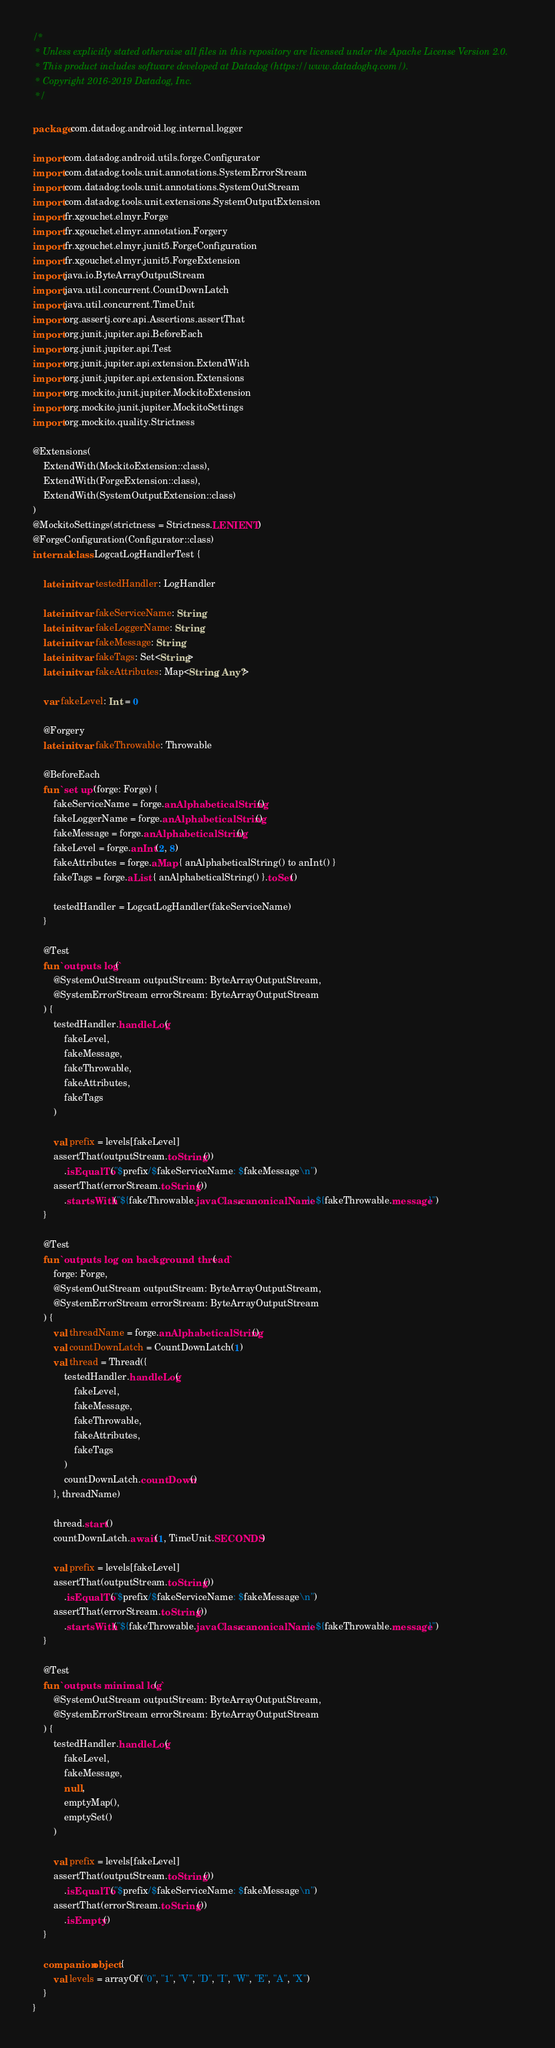Convert code to text. <code><loc_0><loc_0><loc_500><loc_500><_Kotlin_>/*
 * Unless explicitly stated otherwise all files in this repository are licensed under the Apache License Version 2.0.
 * This product includes software developed at Datadog (https://www.datadoghq.com/).
 * Copyright 2016-2019 Datadog, Inc.
 */

package com.datadog.android.log.internal.logger

import com.datadog.android.utils.forge.Configurator
import com.datadog.tools.unit.annotations.SystemErrorStream
import com.datadog.tools.unit.annotations.SystemOutStream
import com.datadog.tools.unit.extensions.SystemOutputExtension
import fr.xgouchet.elmyr.Forge
import fr.xgouchet.elmyr.annotation.Forgery
import fr.xgouchet.elmyr.junit5.ForgeConfiguration
import fr.xgouchet.elmyr.junit5.ForgeExtension
import java.io.ByteArrayOutputStream
import java.util.concurrent.CountDownLatch
import java.util.concurrent.TimeUnit
import org.assertj.core.api.Assertions.assertThat
import org.junit.jupiter.api.BeforeEach
import org.junit.jupiter.api.Test
import org.junit.jupiter.api.extension.ExtendWith
import org.junit.jupiter.api.extension.Extensions
import org.mockito.junit.jupiter.MockitoExtension
import org.mockito.junit.jupiter.MockitoSettings
import org.mockito.quality.Strictness

@Extensions(
    ExtendWith(MockitoExtension::class),
    ExtendWith(ForgeExtension::class),
    ExtendWith(SystemOutputExtension::class)
)
@MockitoSettings(strictness = Strictness.LENIENT)
@ForgeConfiguration(Configurator::class)
internal class LogcatLogHandlerTest {

    lateinit var testedHandler: LogHandler

    lateinit var fakeServiceName: String
    lateinit var fakeLoggerName: String
    lateinit var fakeMessage: String
    lateinit var fakeTags: Set<String>
    lateinit var fakeAttributes: Map<String, Any?>

    var fakeLevel: Int = 0

    @Forgery
    lateinit var fakeThrowable: Throwable

    @BeforeEach
    fun `set up`(forge: Forge) {
        fakeServiceName = forge.anAlphabeticalString()
        fakeLoggerName = forge.anAlphabeticalString()
        fakeMessage = forge.anAlphabeticalString()
        fakeLevel = forge.anInt(2, 8)
        fakeAttributes = forge.aMap { anAlphabeticalString() to anInt() }
        fakeTags = forge.aList { anAlphabeticalString() }.toSet()

        testedHandler = LogcatLogHandler(fakeServiceName)
    }

    @Test
    fun `outputs log`(
        @SystemOutStream outputStream: ByteArrayOutputStream,
        @SystemErrorStream errorStream: ByteArrayOutputStream
    ) {
        testedHandler.handleLog(
            fakeLevel,
            fakeMessage,
            fakeThrowable,
            fakeAttributes,
            fakeTags
        )

        val prefix = levels[fakeLevel]
        assertThat(outputStream.toString())
            .isEqualTo("$prefix/$fakeServiceName: $fakeMessage\n")
        assertThat(errorStream.toString())
            .startsWith("${fakeThrowable.javaClass.canonicalName}: ${fakeThrowable.message}")
    }

    @Test
    fun `outputs log on background thread`(
        forge: Forge,
        @SystemOutStream outputStream: ByteArrayOutputStream,
        @SystemErrorStream errorStream: ByteArrayOutputStream
    ) {
        val threadName = forge.anAlphabeticalString()
        val countDownLatch = CountDownLatch(1)
        val thread = Thread({
            testedHandler.handleLog(
                fakeLevel,
                fakeMessage,
                fakeThrowable,
                fakeAttributes,
                fakeTags
            )
            countDownLatch.countDown()
        }, threadName)

        thread.start()
        countDownLatch.await(1, TimeUnit.SECONDS)

        val prefix = levels[fakeLevel]
        assertThat(outputStream.toString())
            .isEqualTo("$prefix/$fakeServiceName: $fakeMessage\n")
        assertThat(errorStream.toString())
            .startsWith("${fakeThrowable.javaClass.canonicalName}: ${fakeThrowable.message}")
    }

    @Test
    fun `outputs minimal log`(
        @SystemOutStream outputStream: ByteArrayOutputStream,
        @SystemErrorStream errorStream: ByteArrayOutputStream
    ) {
        testedHandler.handleLog(
            fakeLevel,
            fakeMessage,
            null,
            emptyMap(),
            emptySet()
        )

        val prefix = levels[fakeLevel]
        assertThat(outputStream.toString())
            .isEqualTo("$prefix/$fakeServiceName: $fakeMessage\n")
        assertThat(errorStream.toString())
            .isEmpty()
    }

    companion object {
        val levels = arrayOf("0", "1", "V", "D", "I", "W", "E", "A", "X")
    }
}
</code> 